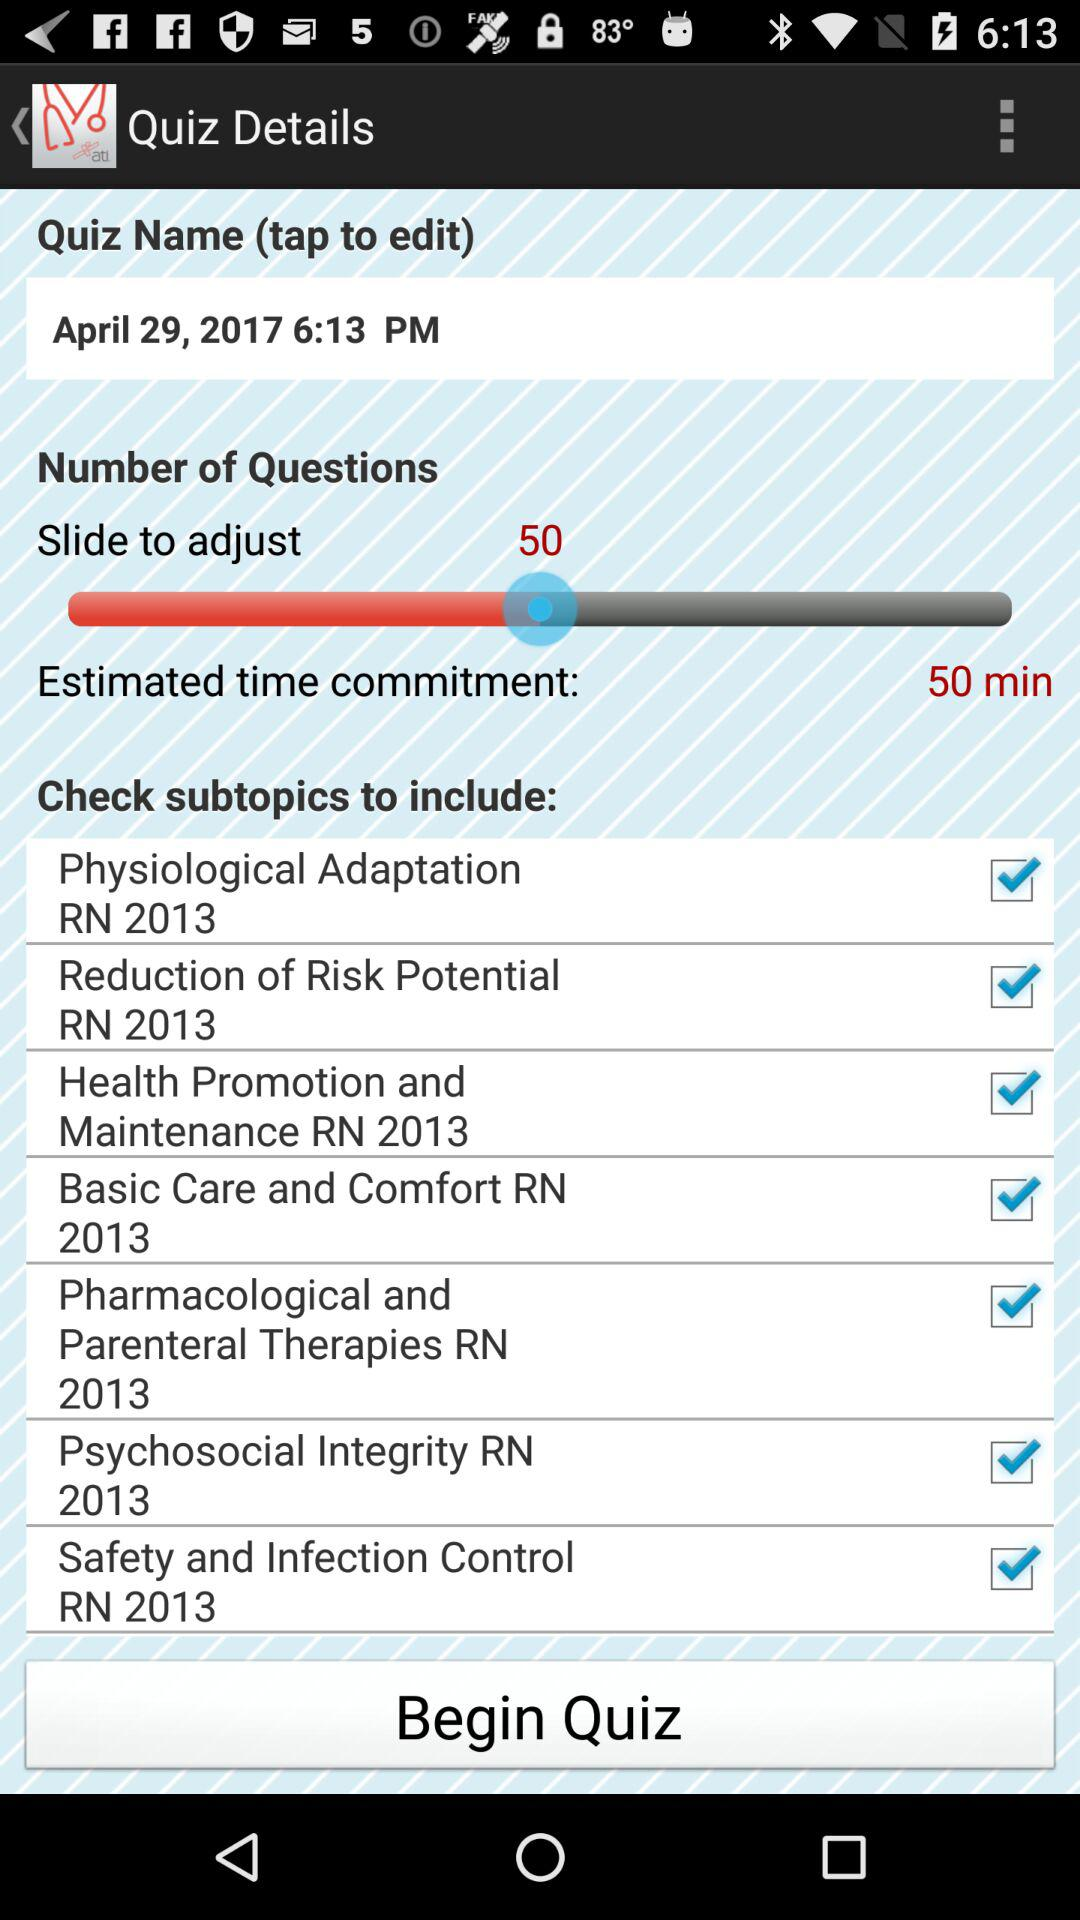What is the estimated time commitment? The estimated time commitment is 50 minutes. 